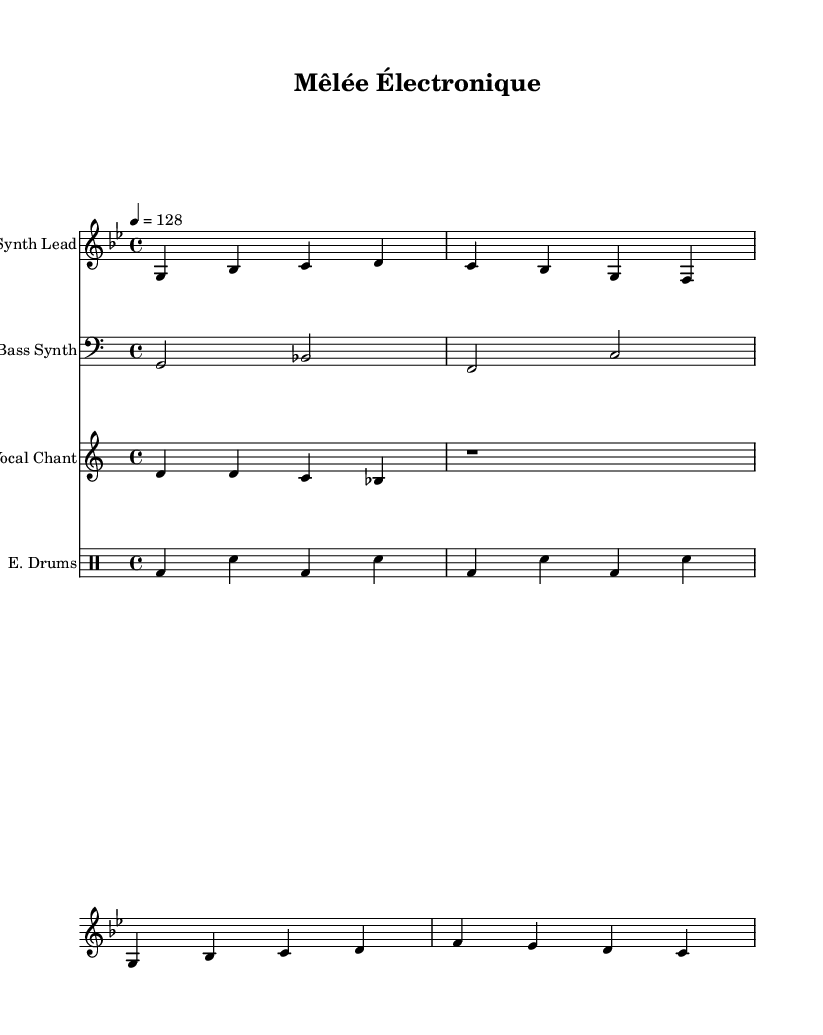What is the key signature of this music? The key signature is G minor, which has two flats (B flat and E flat). This can be determined by looking at the key signature indication at the beginning of the score.
Answer: G minor What is the time signature of this sheet music? The time signature is 4/4, indicated at the beginning of the score. This means there are four beats in each measure and the quarter note receives one beat.
Answer: 4/4 What is the tempo marking for this piece? The tempo marking is indicated as 128, which means the piece is set to play at 128 beats per minute. This is a fairly energetic tempo typical in electronic music.
Answer: 128 How many measures are in the synth lead section? There are four measures in the synth lead section, as defined by the grouped notes between the vertical lines which indicate the measure barriers.
Answer: 4 What chant is used in this composition? The chant used is "Allez les Bleus!" which represents a common rugby chant. This can be identified in the lyrics section aligned with the vocal chant notes.
Answer: Allez les Bleus! Which instrument plays the bass line? The bass line is played by the Bass Synth, as indicated in the staff label for the respective musical line in the score.
Answer: Bass Synth What type of drums are indicated in this score? The score indicates E. Drums, referring to electronic drums, which are commonly used in fusion and electronic music. This is visible in the drum staff labeling.
Answer: E. Drums 